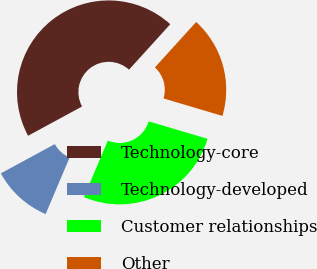<chart> <loc_0><loc_0><loc_500><loc_500><pie_chart><fcel>Technology-core<fcel>Technology-developed<fcel>Customer relationships<fcel>Other<nl><fcel>44.64%<fcel>10.71%<fcel>26.79%<fcel>17.86%<nl></chart> 